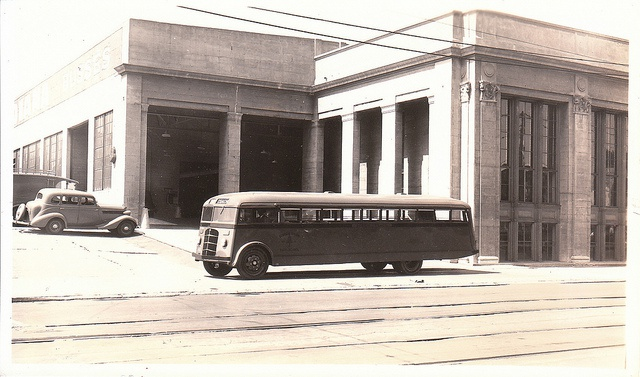Describe the objects in this image and their specific colors. I can see bus in lightgray, black, gray, and ivory tones, car in lightgray, gray, ivory, and darkgray tones, and truck in lightgray, gray, white, and darkgray tones in this image. 